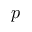<formula> <loc_0><loc_0><loc_500><loc_500>p</formula> 